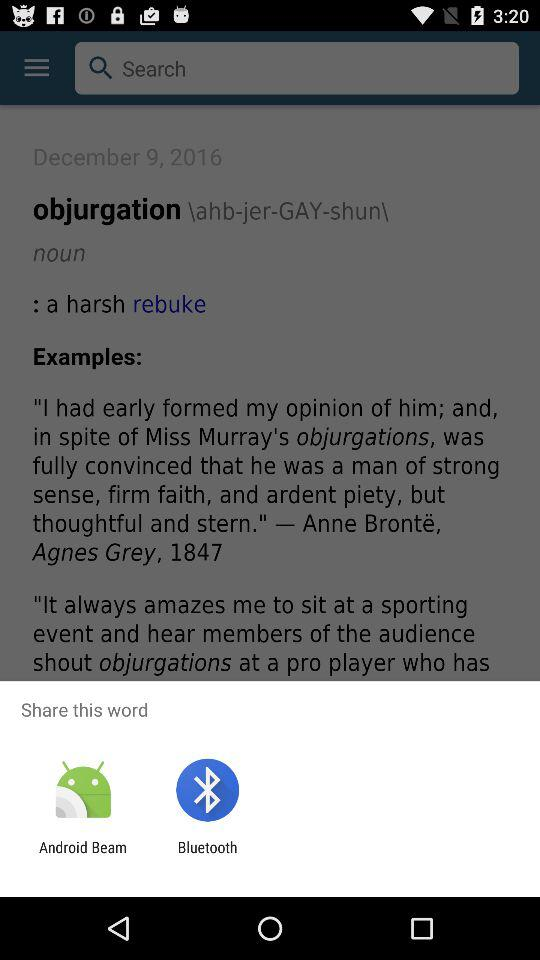Through which application can we share? You can share through "Android Beam" and "Bluetooth". 